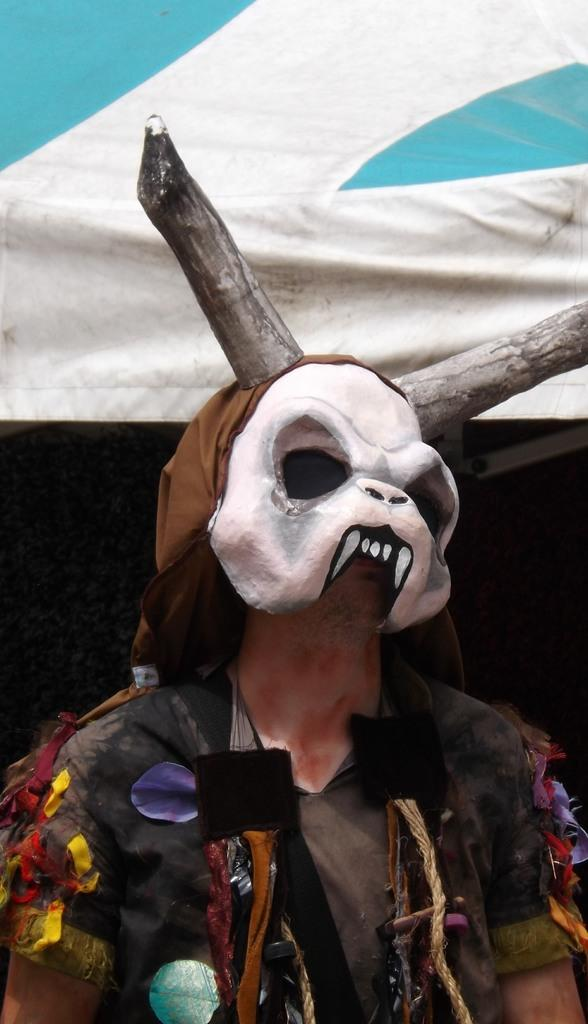Who or what is present in the image? There is a person in the image. What is the person wearing? The person is wearing a mask. What structure can be seen behind the person? There is a tent behind the person. What is the chance of a monkey appearing in the image? There is no monkey present in the image, so it's not possible to determine the chance of one appearing. 